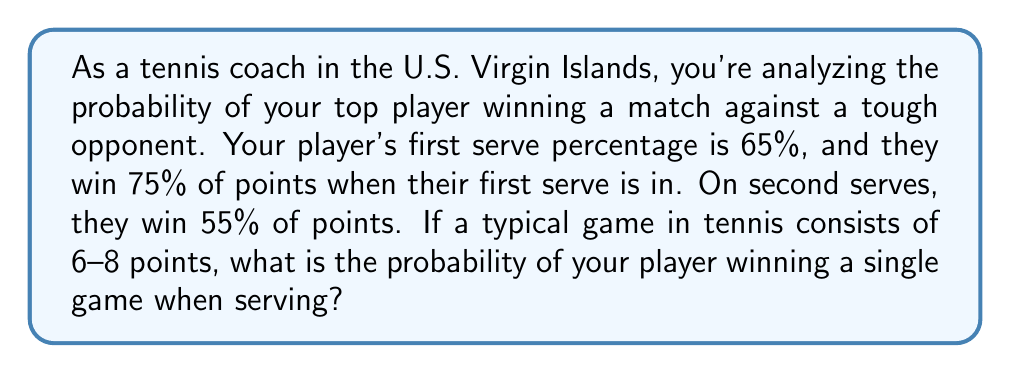Teach me how to tackle this problem. Let's approach this step-by-step:

1) First, we need to calculate the probability of winning a point on serve. This depends on whether the first serve is in or not.

   Probability of first serve in = 0.65
   Probability of first serve out = 1 - 0.65 = 0.35

2) The probability of winning a point can be calculated as:

   $P(\text{win point}) = P(\text{1st serve in}) \cdot P(\text{win on 1st serve}) + P(\text{1st serve out}) \cdot P(\text{win on 2nd serve})$

   $P(\text{win point}) = 0.65 \cdot 0.75 + 0.35 \cdot 0.55 = 0.4875 + 0.1925 = 0.68$

3) Now, to win a game, a player needs to win 4 points before the opponent wins 4 points. This follows a negative binomial distribution.

4) The probability of winning a game can be calculated using the following formula:

   $P(\text{win game}) = \sum_{k=4}^{7} \binom{k+3}{k} p^k (1-p)^3$

   Where $p$ is the probability of winning a point (0.68 in this case).

5) Let's calculate each term:

   For $k=4$: $\binom{7}{4} 0.68^4 (0.32)^3 = 0.2166$
   For $k=5$: $\binom{8}{5} 0.68^5 (0.32)^3 = 0.1855$
   For $k=6$: $\binom{9}{6} 0.68^6 (0.32)^3 = 0.1060$
   For $k=7$: $\binom{10}{7} 0.68^7 (0.32)^3 = 0.0424$

6) Sum these probabilities:

   $P(\text{win game}) = 0.2166 + 0.1855 + 0.1060 + 0.0424 = 0.5505$

Therefore, the probability of your player winning a single game when serving is approximately 0.5505 or 55.05%.
Answer: 0.5505 or 55.05% 